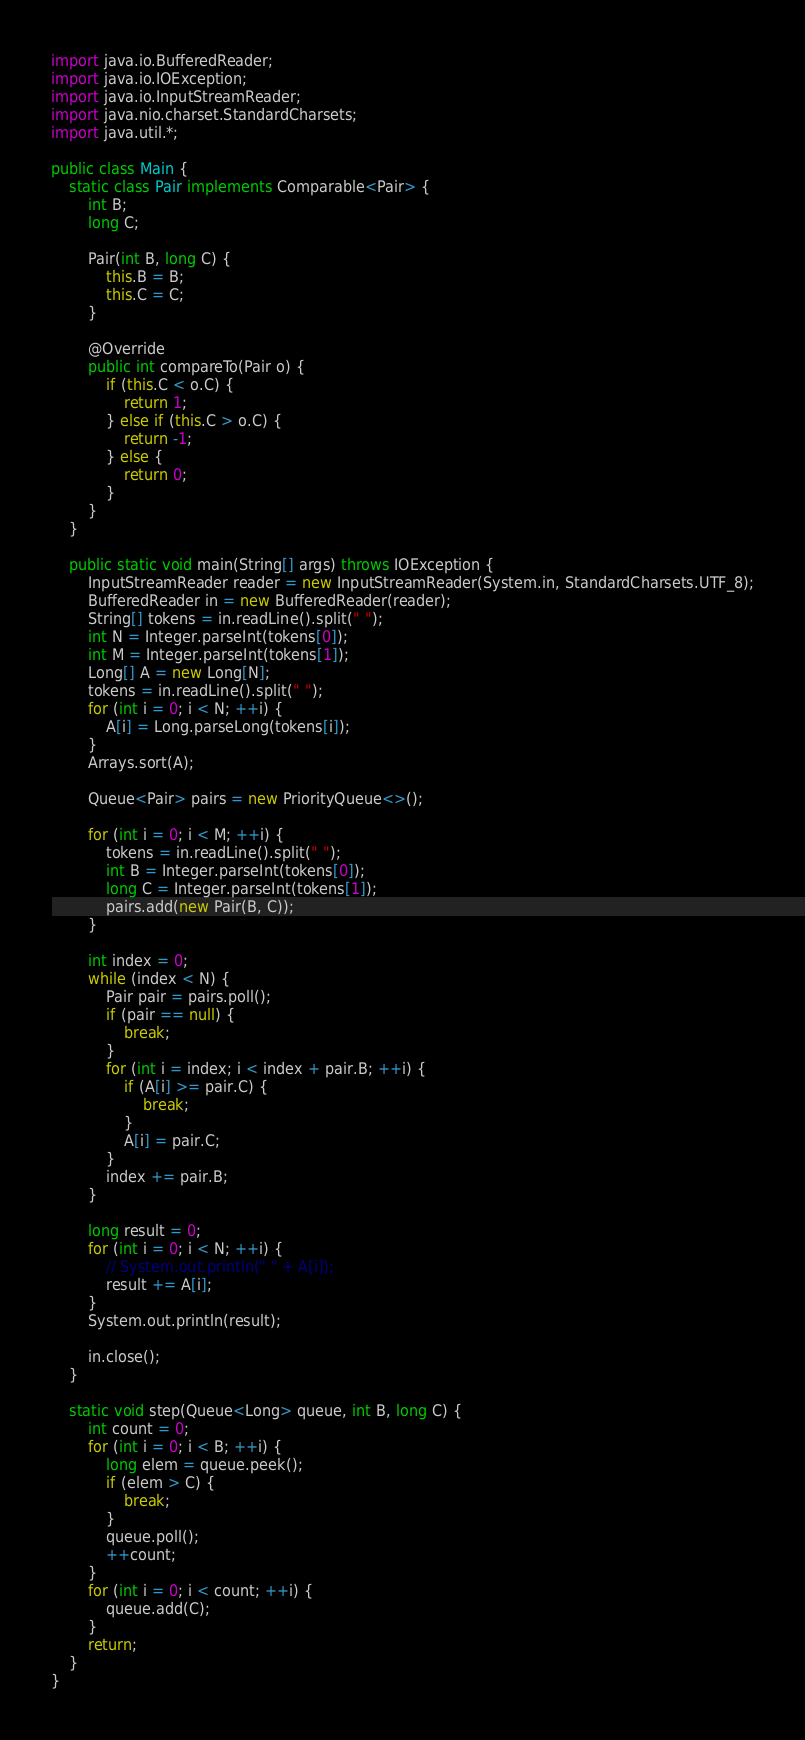Convert code to text. <code><loc_0><loc_0><loc_500><loc_500><_Java_>import java.io.BufferedReader;
import java.io.IOException;
import java.io.InputStreamReader;
import java.nio.charset.StandardCharsets;
import java.util.*;

public class Main {
	static class Pair implements Comparable<Pair> {
		int B;
		long C;

		Pair(int B, long C) {
			this.B = B;
			this.C = C;
		}

		@Override
		public int compareTo(Pair o) {
			if (this.C < o.C) {
				return 1;
			} else if (this.C > o.C) {
				return -1;
			} else {
				return 0;
			}
		}
	}

	public static void main(String[] args) throws IOException {
		InputStreamReader reader = new InputStreamReader(System.in, StandardCharsets.UTF_8);
		BufferedReader in = new BufferedReader(reader);
		String[] tokens = in.readLine().split(" ");
		int N = Integer.parseInt(tokens[0]);
		int M = Integer.parseInt(tokens[1]);
		Long[] A = new Long[N];
		tokens = in.readLine().split(" ");
		for (int i = 0; i < N; ++i) {
			A[i] = Long.parseLong(tokens[i]);
		}
		Arrays.sort(A);

		Queue<Pair> pairs = new PriorityQueue<>();

		for (int i = 0; i < M; ++i) {
			tokens = in.readLine().split(" ");
			int B = Integer.parseInt(tokens[0]);
			long C = Integer.parseInt(tokens[1]);
			pairs.add(new Pair(B, C));
		}

		int index = 0;
		while (index < N) {
			Pair pair = pairs.poll();
			if (pair == null) {
				break;
			}
			for (int i = index; i < index + pair.B; ++i) {
				if (A[i] >= pair.C) {
					break;
				}
				A[i] = pair.C;
			}
			index += pair.B;
		}

		long result = 0;
		for (int i = 0; i < N; ++i) {
			// System.out.println(" " + A[i]);
			result += A[i];
		}
		System.out.println(result);

		in.close();
	}

	static void step(Queue<Long> queue, int B, long C) {
		int count = 0;
		for (int i = 0; i < B; ++i) {
			long elem = queue.peek();
			if (elem > C) {
				break;
			}
			queue.poll();
			++count;
		}
		for (int i = 0; i < count; ++i) {
			queue.add(C);
		}
		return;
	}
}</code> 